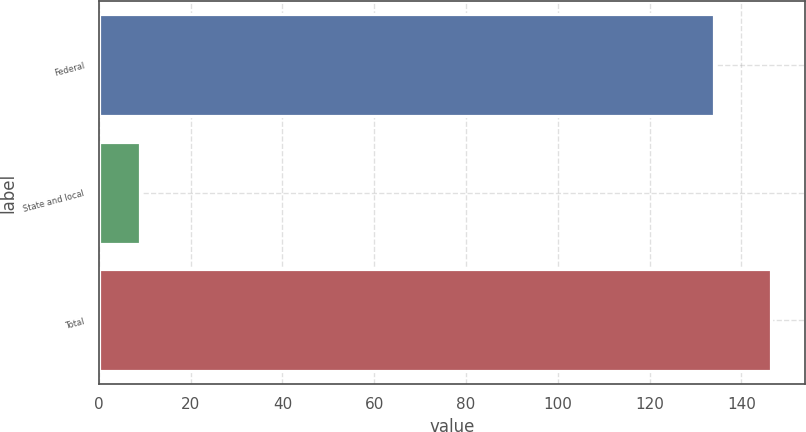Convert chart. <chart><loc_0><loc_0><loc_500><loc_500><bar_chart><fcel>Federal<fcel>State and local<fcel>Total<nl><fcel>134<fcel>9<fcel>146.5<nl></chart> 